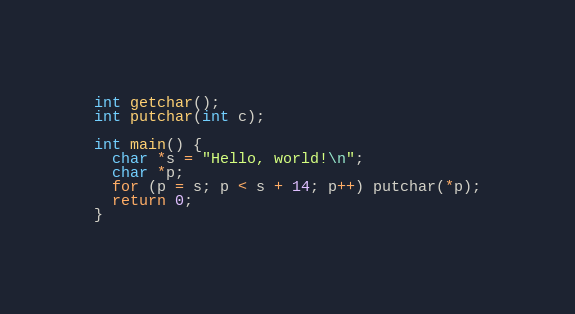Convert code to text. <code><loc_0><loc_0><loc_500><loc_500><_C_>int getchar();
int putchar(int c);

int main() {
  char *s = "Hello, world!\n";
  char *p;
  for (p = s; p < s + 14; p++) putchar(*p);
  return 0;
}
</code> 